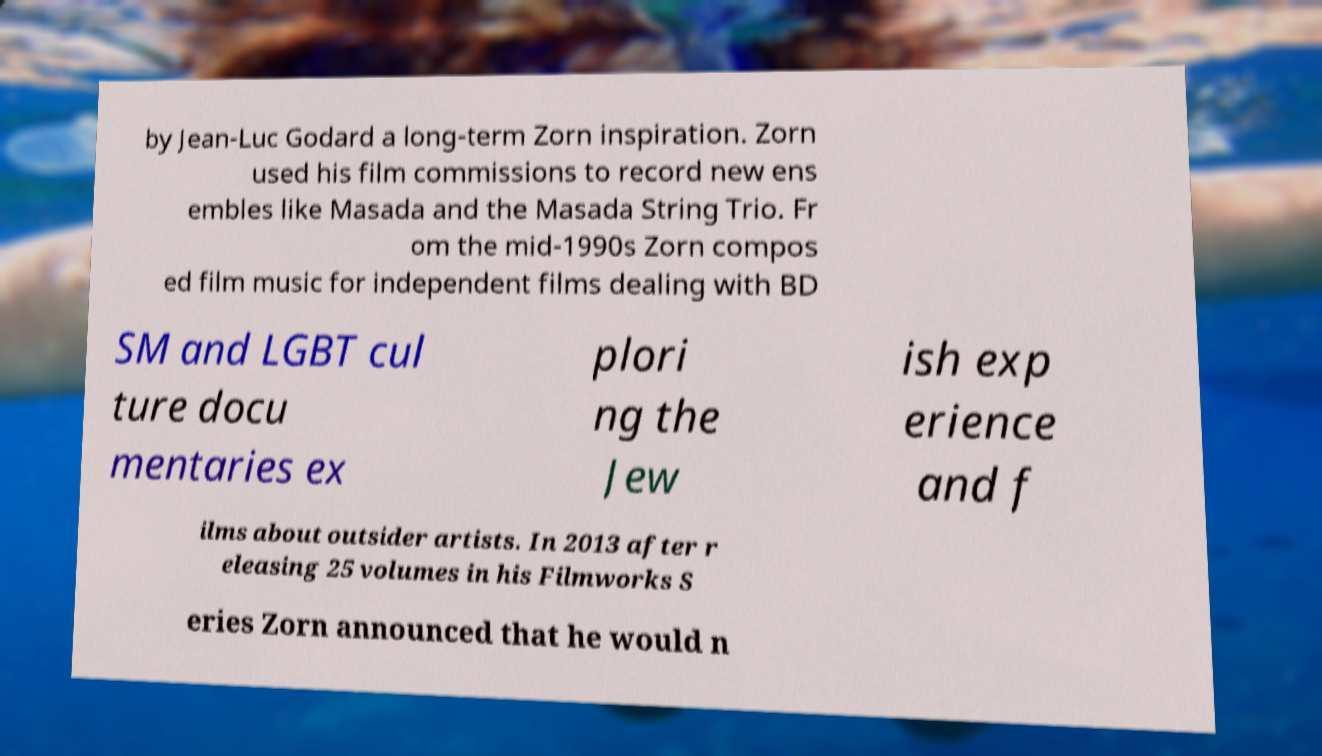Can you accurately transcribe the text from the provided image for me? by Jean-Luc Godard a long-term Zorn inspiration. Zorn used his film commissions to record new ens embles like Masada and the Masada String Trio. Fr om the mid-1990s Zorn compos ed film music for independent films dealing with BD SM and LGBT cul ture docu mentaries ex plori ng the Jew ish exp erience and f ilms about outsider artists. In 2013 after r eleasing 25 volumes in his Filmworks S eries Zorn announced that he would n 